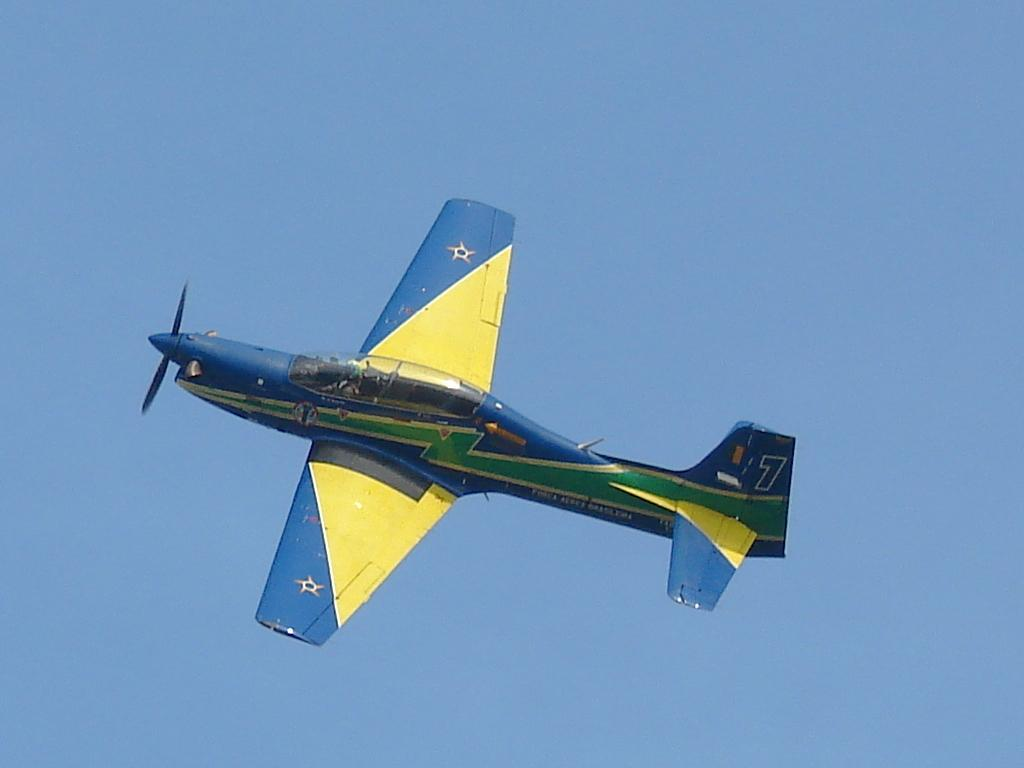What is the main subject of the image? The main subject of the image is an aircraft. Where is the aircraft located in the image? The aircraft is in the sky. What is the weight of the bell hanging from the aircraft in the image? There is no bell hanging from the aircraft in the image. 